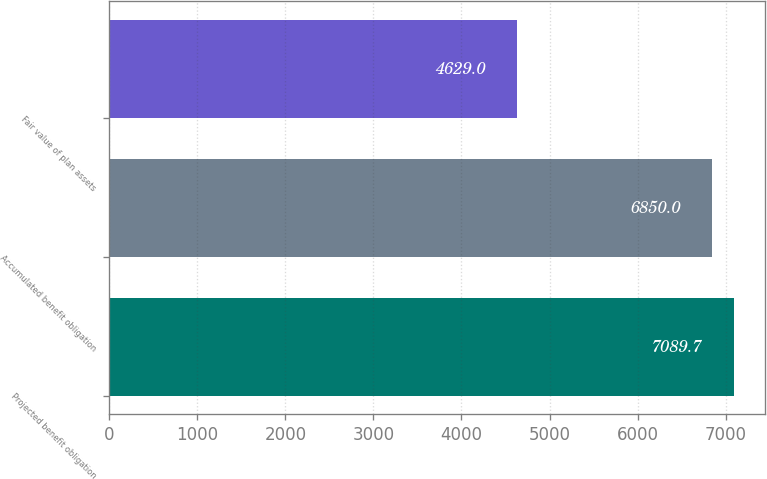Convert chart to OTSL. <chart><loc_0><loc_0><loc_500><loc_500><bar_chart><fcel>Projected benefit obligation<fcel>Accumulated benefit obligation<fcel>Fair value of plan assets<nl><fcel>7089.7<fcel>6850<fcel>4629<nl></chart> 